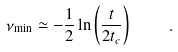<formula> <loc_0><loc_0><loc_500><loc_500>\nu _ { \min } \simeq - \frac { 1 } { 2 } \ln \left ( \frac { t } { 2 t _ { c } } \right ) \quad .</formula> 